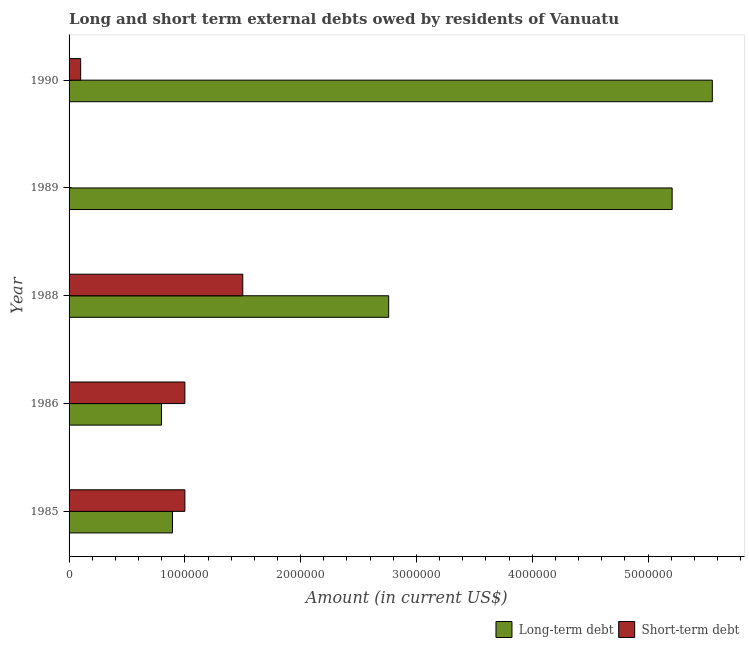How many bars are there on the 4th tick from the top?
Offer a terse response. 2. How many bars are there on the 5th tick from the bottom?
Ensure brevity in your answer.  2. In how many cases, is the number of bars for a given year not equal to the number of legend labels?
Provide a short and direct response. 1. What is the long-term debts owed by residents in 1990?
Your answer should be very brief. 5.56e+06. Across all years, what is the maximum short-term debts owed by residents?
Your answer should be compact. 1.50e+06. In which year was the long-term debts owed by residents maximum?
Make the answer very short. 1990. What is the total short-term debts owed by residents in the graph?
Make the answer very short. 3.60e+06. What is the difference between the long-term debts owed by residents in 1986 and that in 1988?
Offer a very short reply. -1.96e+06. What is the difference between the long-term debts owed by residents in 1989 and the short-term debts owed by residents in 1986?
Give a very brief answer. 4.21e+06. What is the average short-term debts owed by residents per year?
Offer a terse response. 7.20e+05. In the year 1986, what is the difference between the long-term debts owed by residents and short-term debts owed by residents?
Your response must be concise. -2.02e+05. Is the long-term debts owed by residents in 1985 less than that in 1988?
Offer a terse response. Yes. Is the difference between the long-term debts owed by residents in 1985 and 1986 greater than the difference between the short-term debts owed by residents in 1985 and 1986?
Your answer should be very brief. Yes. What is the difference between the highest and the lowest short-term debts owed by residents?
Give a very brief answer. 1.50e+06. Is the sum of the long-term debts owed by residents in 1985 and 1988 greater than the maximum short-term debts owed by residents across all years?
Provide a succinct answer. Yes. What is the difference between two consecutive major ticks on the X-axis?
Ensure brevity in your answer.  1.00e+06. Are the values on the major ticks of X-axis written in scientific E-notation?
Make the answer very short. No. How are the legend labels stacked?
Make the answer very short. Horizontal. What is the title of the graph?
Give a very brief answer. Long and short term external debts owed by residents of Vanuatu. What is the Amount (in current US$) in Long-term debt in 1985?
Your response must be concise. 8.93e+05. What is the Amount (in current US$) in Short-term debt in 1985?
Offer a terse response. 1.00e+06. What is the Amount (in current US$) of Long-term debt in 1986?
Make the answer very short. 7.98e+05. What is the Amount (in current US$) in Long-term debt in 1988?
Make the answer very short. 2.76e+06. What is the Amount (in current US$) of Short-term debt in 1988?
Keep it short and to the point. 1.50e+06. What is the Amount (in current US$) of Long-term debt in 1989?
Provide a succinct answer. 5.21e+06. What is the Amount (in current US$) in Short-term debt in 1989?
Keep it short and to the point. 0. What is the Amount (in current US$) of Long-term debt in 1990?
Provide a succinct answer. 5.56e+06. What is the Amount (in current US$) of Short-term debt in 1990?
Provide a succinct answer. 1.00e+05. Across all years, what is the maximum Amount (in current US$) in Long-term debt?
Ensure brevity in your answer.  5.56e+06. Across all years, what is the maximum Amount (in current US$) of Short-term debt?
Your response must be concise. 1.50e+06. Across all years, what is the minimum Amount (in current US$) of Long-term debt?
Provide a short and direct response. 7.98e+05. What is the total Amount (in current US$) of Long-term debt in the graph?
Provide a succinct answer. 1.52e+07. What is the total Amount (in current US$) in Short-term debt in the graph?
Provide a short and direct response. 3.60e+06. What is the difference between the Amount (in current US$) in Long-term debt in 1985 and that in 1986?
Give a very brief answer. 9.50e+04. What is the difference between the Amount (in current US$) in Short-term debt in 1985 and that in 1986?
Offer a very short reply. 0. What is the difference between the Amount (in current US$) of Long-term debt in 1985 and that in 1988?
Keep it short and to the point. -1.87e+06. What is the difference between the Amount (in current US$) of Short-term debt in 1985 and that in 1988?
Your response must be concise. -5.00e+05. What is the difference between the Amount (in current US$) of Long-term debt in 1985 and that in 1989?
Provide a succinct answer. -4.32e+06. What is the difference between the Amount (in current US$) of Long-term debt in 1985 and that in 1990?
Keep it short and to the point. -4.66e+06. What is the difference between the Amount (in current US$) of Long-term debt in 1986 and that in 1988?
Provide a short and direct response. -1.96e+06. What is the difference between the Amount (in current US$) of Short-term debt in 1986 and that in 1988?
Offer a terse response. -5.00e+05. What is the difference between the Amount (in current US$) of Long-term debt in 1986 and that in 1989?
Keep it short and to the point. -4.41e+06. What is the difference between the Amount (in current US$) in Long-term debt in 1986 and that in 1990?
Give a very brief answer. -4.76e+06. What is the difference between the Amount (in current US$) of Long-term debt in 1988 and that in 1989?
Keep it short and to the point. -2.45e+06. What is the difference between the Amount (in current US$) of Long-term debt in 1988 and that in 1990?
Ensure brevity in your answer.  -2.80e+06. What is the difference between the Amount (in current US$) in Short-term debt in 1988 and that in 1990?
Your answer should be compact. 1.40e+06. What is the difference between the Amount (in current US$) in Long-term debt in 1989 and that in 1990?
Provide a succinct answer. -3.47e+05. What is the difference between the Amount (in current US$) of Long-term debt in 1985 and the Amount (in current US$) of Short-term debt in 1986?
Provide a short and direct response. -1.07e+05. What is the difference between the Amount (in current US$) of Long-term debt in 1985 and the Amount (in current US$) of Short-term debt in 1988?
Your answer should be compact. -6.07e+05. What is the difference between the Amount (in current US$) of Long-term debt in 1985 and the Amount (in current US$) of Short-term debt in 1990?
Provide a succinct answer. 7.93e+05. What is the difference between the Amount (in current US$) of Long-term debt in 1986 and the Amount (in current US$) of Short-term debt in 1988?
Your answer should be very brief. -7.02e+05. What is the difference between the Amount (in current US$) in Long-term debt in 1986 and the Amount (in current US$) in Short-term debt in 1990?
Ensure brevity in your answer.  6.98e+05. What is the difference between the Amount (in current US$) of Long-term debt in 1988 and the Amount (in current US$) of Short-term debt in 1990?
Provide a short and direct response. 2.66e+06. What is the difference between the Amount (in current US$) in Long-term debt in 1989 and the Amount (in current US$) in Short-term debt in 1990?
Offer a very short reply. 5.11e+06. What is the average Amount (in current US$) of Long-term debt per year?
Provide a short and direct response. 3.04e+06. What is the average Amount (in current US$) in Short-term debt per year?
Your answer should be compact. 7.20e+05. In the year 1985, what is the difference between the Amount (in current US$) in Long-term debt and Amount (in current US$) in Short-term debt?
Your answer should be very brief. -1.07e+05. In the year 1986, what is the difference between the Amount (in current US$) in Long-term debt and Amount (in current US$) in Short-term debt?
Keep it short and to the point. -2.02e+05. In the year 1988, what is the difference between the Amount (in current US$) of Long-term debt and Amount (in current US$) of Short-term debt?
Provide a short and direct response. 1.26e+06. In the year 1990, what is the difference between the Amount (in current US$) of Long-term debt and Amount (in current US$) of Short-term debt?
Make the answer very short. 5.46e+06. What is the ratio of the Amount (in current US$) in Long-term debt in 1985 to that in 1986?
Give a very brief answer. 1.12. What is the ratio of the Amount (in current US$) in Long-term debt in 1985 to that in 1988?
Your answer should be compact. 0.32. What is the ratio of the Amount (in current US$) of Short-term debt in 1985 to that in 1988?
Ensure brevity in your answer.  0.67. What is the ratio of the Amount (in current US$) of Long-term debt in 1985 to that in 1989?
Your answer should be compact. 0.17. What is the ratio of the Amount (in current US$) in Long-term debt in 1985 to that in 1990?
Make the answer very short. 0.16. What is the ratio of the Amount (in current US$) in Long-term debt in 1986 to that in 1988?
Provide a succinct answer. 0.29. What is the ratio of the Amount (in current US$) in Long-term debt in 1986 to that in 1989?
Your answer should be compact. 0.15. What is the ratio of the Amount (in current US$) of Long-term debt in 1986 to that in 1990?
Offer a very short reply. 0.14. What is the ratio of the Amount (in current US$) in Long-term debt in 1988 to that in 1989?
Provide a short and direct response. 0.53. What is the ratio of the Amount (in current US$) of Long-term debt in 1988 to that in 1990?
Keep it short and to the point. 0.5. What is the ratio of the Amount (in current US$) of Short-term debt in 1988 to that in 1990?
Keep it short and to the point. 15. What is the ratio of the Amount (in current US$) in Long-term debt in 1989 to that in 1990?
Make the answer very short. 0.94. What is the difference between the highest and the second highest Amount (in current US$) of Long-term debt?
Keep it short and to the point. 3.47e+05. What is the difference between the highest and the lowest Amount (in current US$) of Long-term debt?
Provide a succinct answer. 4.76e+06. What is the difference between the highest and the lowest Amount (in current US$) of Short-term debt?
Provide a short and direct response. 1.50e+06. 